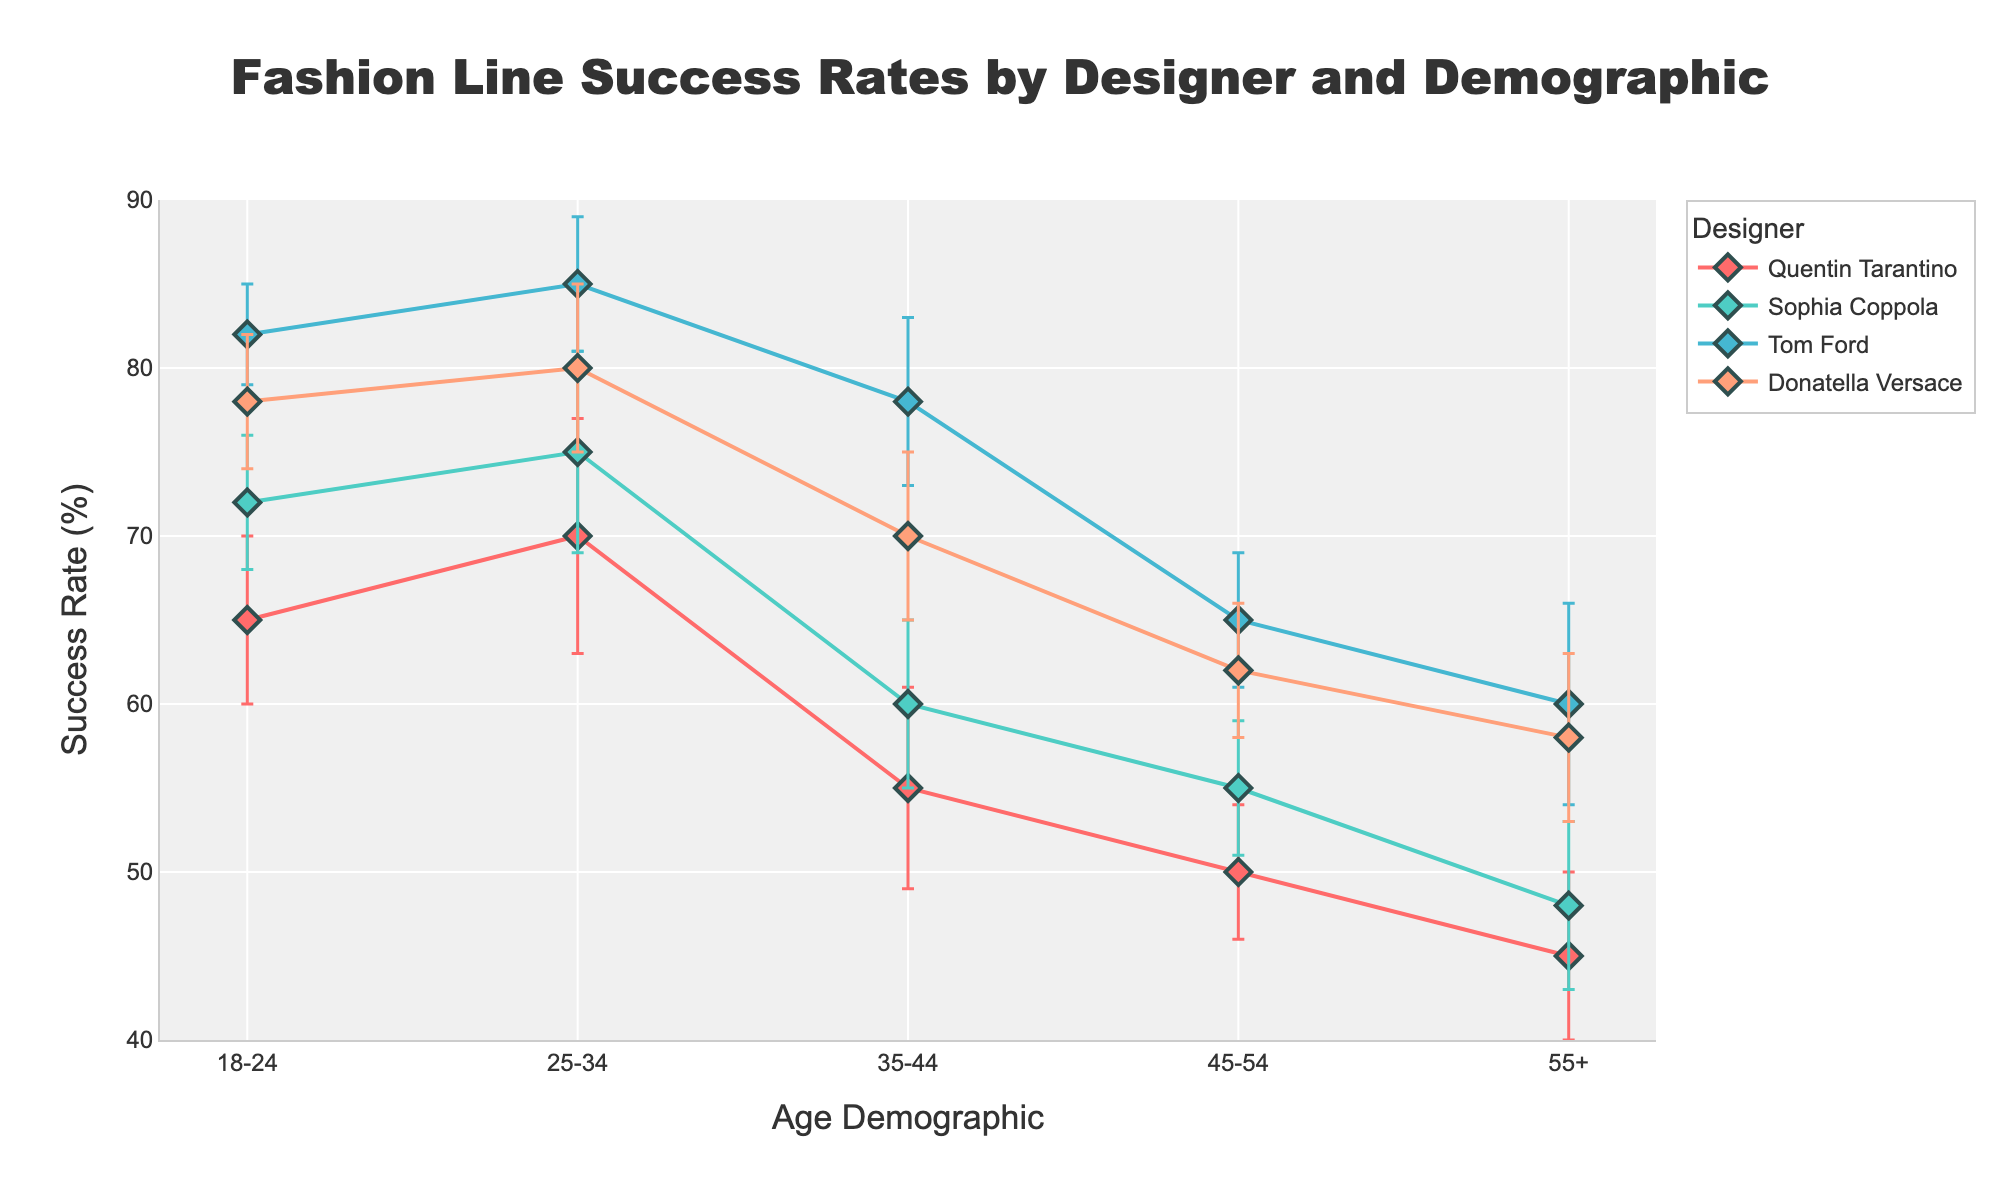What's the title of the figure? The title is usually displayed prominently at the top of the figure. It provides an overview of what the plot is about.
Answer: Fashion Line Success Rates by Designer and Demographic What is the x-axis label? The x-axis label typically describes what the horizontal axis represents. In this plot, it details the different age groups being analyzed.
Answer: Age Demographic What is the y-axis label? The y-axis label usually describes what the vertical axis represents. In this plot, it explains what the measured success rate is.
Answer: Success Rate (%) Which designer has the highest success rate for the 25-34 age demographic? To determine this, look for the highest point on the y-axis within the 25-34 age range. The plot shows Tom Ford has the highest success rate in this demographic.
Answer: Tom Ford How does the success rate of Quentin Tarantino's fashion line change with age? Review Quentin Tarantino's plot line across the different age demographics. You'll see his success rate declines as the age demographic increases.
Answer: It declines with age What is the range of the success rates for Sophia Coppola's fashion line? Identify the highest and lowest success rates for Sophia Coppola from the plot. The success rates range from 48% in the 55+ demographic to 75% in the 25-34 demographic.
Answer: 48% to 75% Which age demographic has the lowest success rate for Donatella Versace's fashion line? Find the lowest-point on Donatella Versace's plot line. The data shows the 55+ age demographic has her lowest success rate.
Answer: 55+ Between the 18-24 and 35-44 age demographics, do traditional fashion designers outperform film directors in success rates? Review the success rates for traditional designers (Tom Ford, Donatella Versace) and film directors (Quentin Tarantino, Sophia Coppola). In both age demographics, traditional designers (both Tom Ford and Donatella Versace) have higher success rates.
Answer: Yes Who has the smallest variability in success rates across all age demographics? To find this answer, compare the error bars (standard deviations) for each designer across all demographics. The smallest overall variability is seen in Quentin Tarantino's and Donatella Versace's plots.
Answer: Quentin Tarantino/Donatella Versace What is the average success rate for film directors in the 18-24 age demographic? Identify the success rates for Quentin Tarantino and Sophia Coppola in the 18-24 age group, sum them up and divide by 2. (65+72)/2 = 68.5.
Answer: 68.5% 